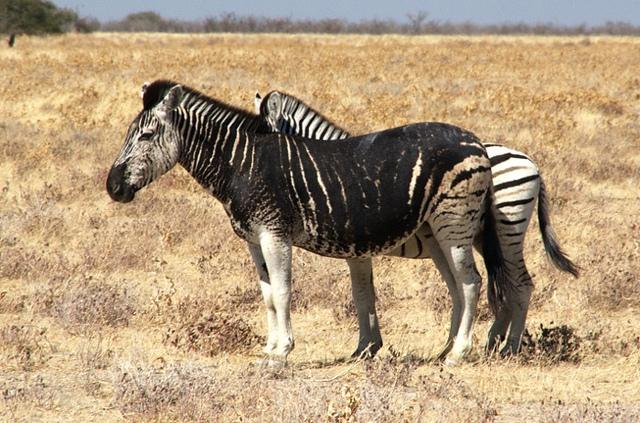What is unusual about the zebra in front?
Answer briefly. Mostly black. What color stripes are missing?
Keep it brief. White. What color is the grass?
Concise answer only. Brown. 